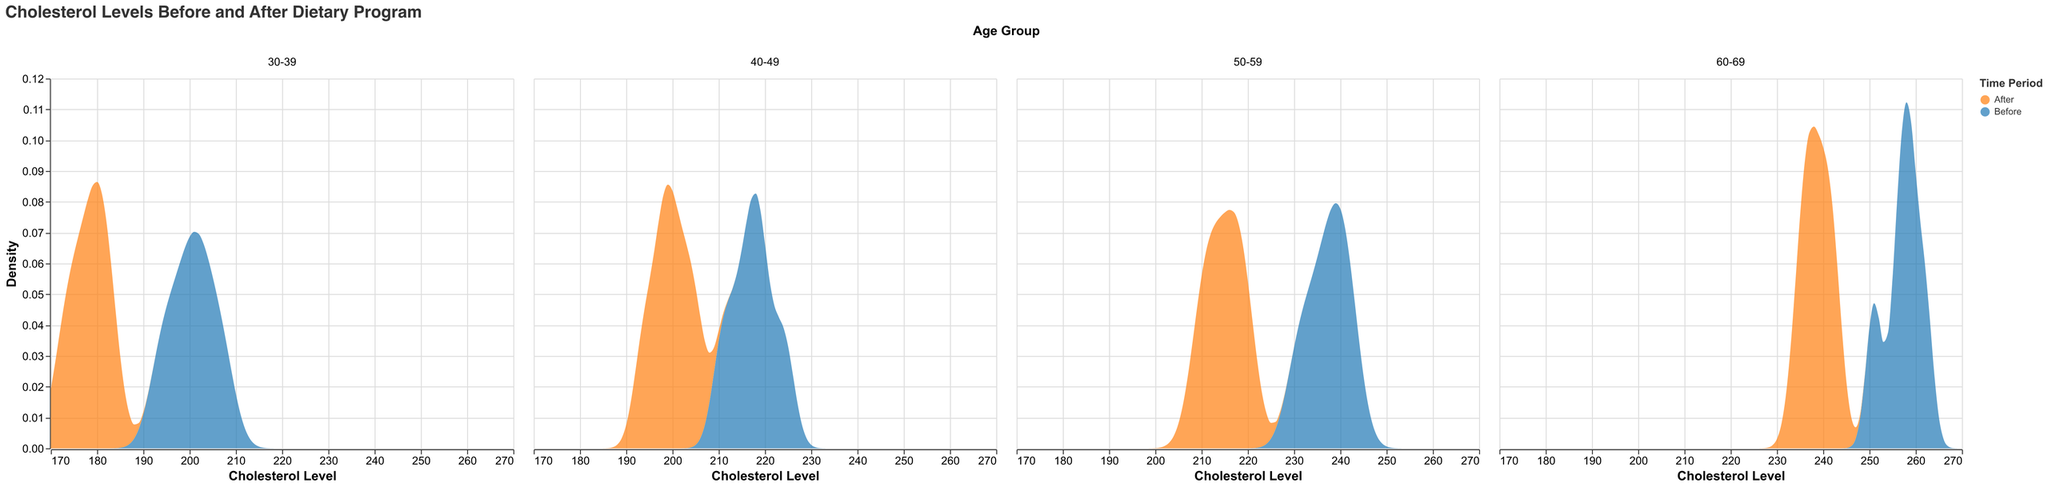What is the main title of the plot? The main title is displayed at the top of the figure and serves to describe the overall contents of the plot. It reads "Cholesterol Levels Before and After Dietary Program."
Answer: Cholesterol Levels Before and After Dietary Program What does the x-axis represent in this plot? The x-axis, labeled "Cholesterol Level," represents the range of cholesterol levels observed in the data. This axis ranges from 170 to 270.
Answer: Cholesterol Level Which age group experienced the most significant shift in cholesterol levels after the dietary program? To determine this, look for the age group where the density plots for 'Before' and 'After' show the greatest horizontal separation. The age group 60-69 shows a noticeable shift from a higher density of cholesterol levels around 258 before the program to around 238 after the program.
Answer: 60-69 How do the density plots for the 30-39 age group compare before and after the dietary program? The density plots for the 30-39 age group before the program peak around 200-205 cholesterol levels. After the program, the peak density shifts to around 175-180 cholesterol levels. This indicates a lowering of cholesterol levels in this age group.
Answer: The after plot shows lower cholesterol levels In the 50-59 age group, which time period shows a higher density at cholesterol levels of 215? Check for the density curves at the cholesterol level of 215 for the 50-59 age group. The 'After' plot has a visible density peak near 215, whereas the 'Before' plot has lower density values at this level, indicating a higher density after the program.
Answer: After What general trend is observed in cholesterol levels for all age groups after the dietary program? As seen from the density plots for all age groups, the general trend is a shift towards lower cholesterol levels. Specifically, the peak densities for 'After' are at lower cholesterol levels compared to 'Before' in all age groups.
Answer: Lower cholesterol levels Is there any age group where the dietary program did not significantly alter the cholesterol levels? Observe the density plots for each age group. The age group with the least noticeable shift in peak density between 'Before' and 'After' indicates minimal change. The 40-49 age group shows the smallest shift compared to others.
Answer: 40-49 